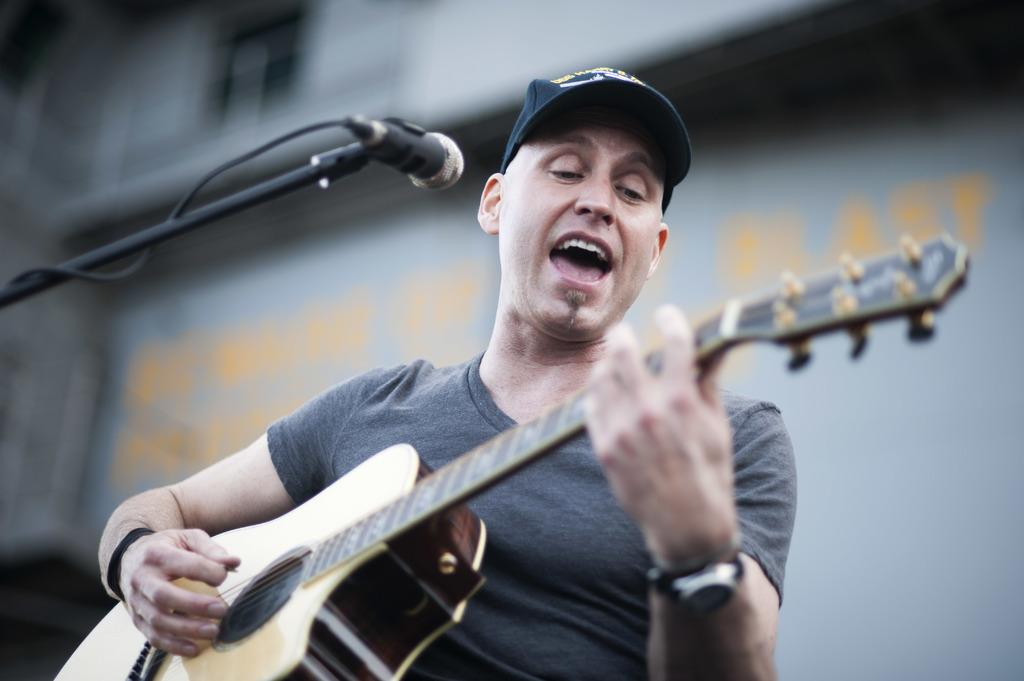What is the man in the image doing? The man is playing a guitar and singing. What object is in front of the man? There is a microphone in front of the man. What type of banana can be seen being lifted by the rake in the image? There is no banana, lift, or rake present in the image. 